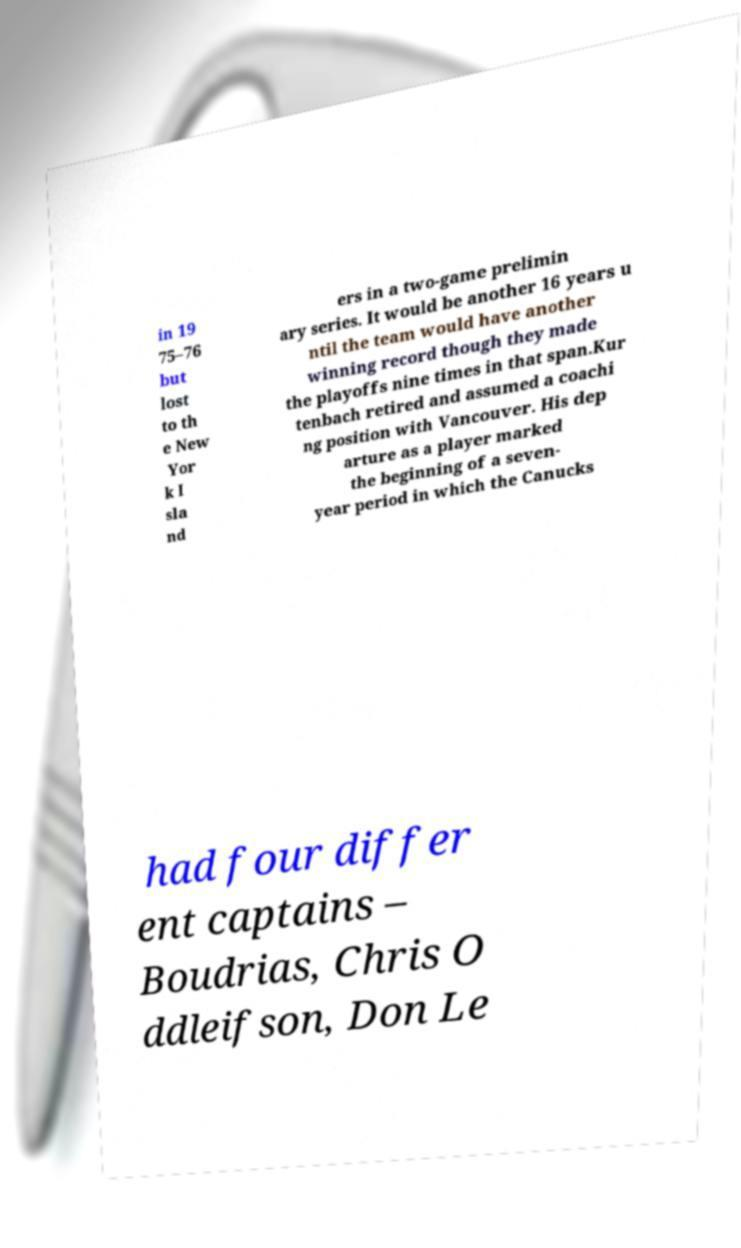Could you extract and type out the text from this image? in 19 75–76 but lost to th e New Yor k I sla nd ers in a two-game prelimin ary series. It would be another 16 years u ntil the team would have another winning record though they made the playoffs nine times in that span.Kur tenbach retired and assumed a coachi ng position with Vancouver. His dep arture as a player marked the beginning of a seven- year period in which the Canucks had four differ ent captains – Boudrias, Chris O ddleifson, Don Le 